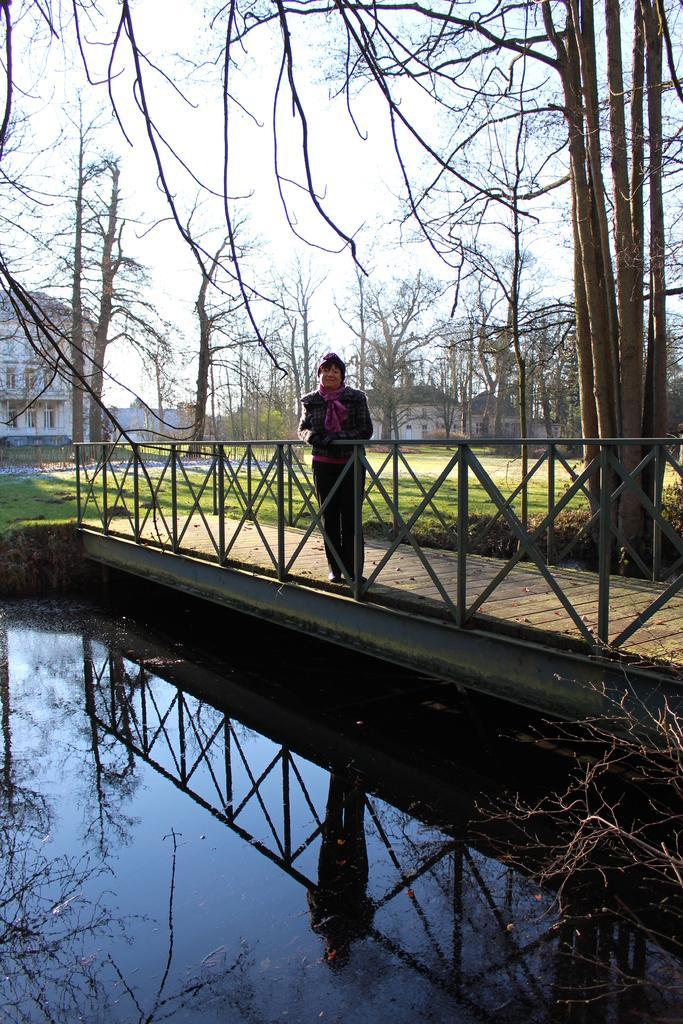How would you summarize this image in a sentence or two? The man in the middle of the picture wearing black jacket is standing on the bridge. Beside him, we see an iron railing. Beside that, we see water. In the background, there are many trees and buildings. At the top of the picture, we see the sky. Behind the man, we see grass. 